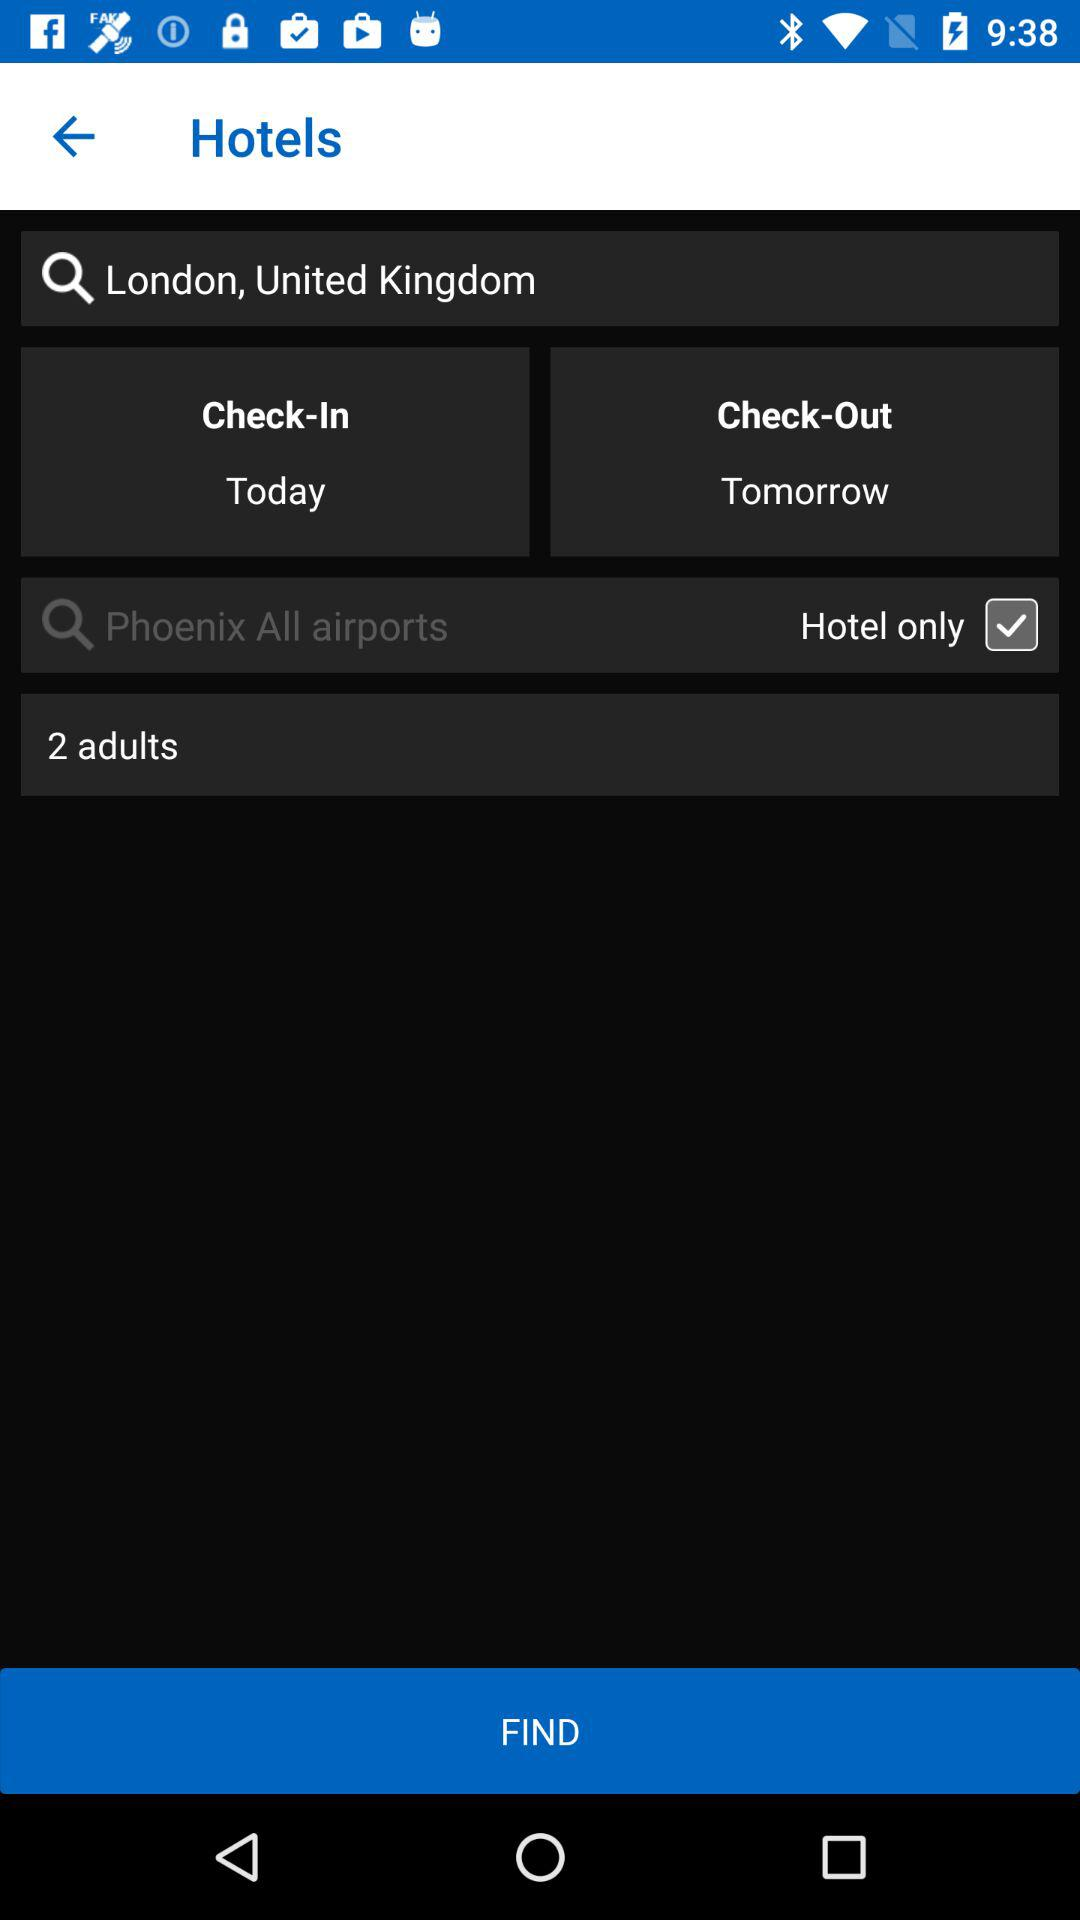What day is selected for check in? The day is today. 